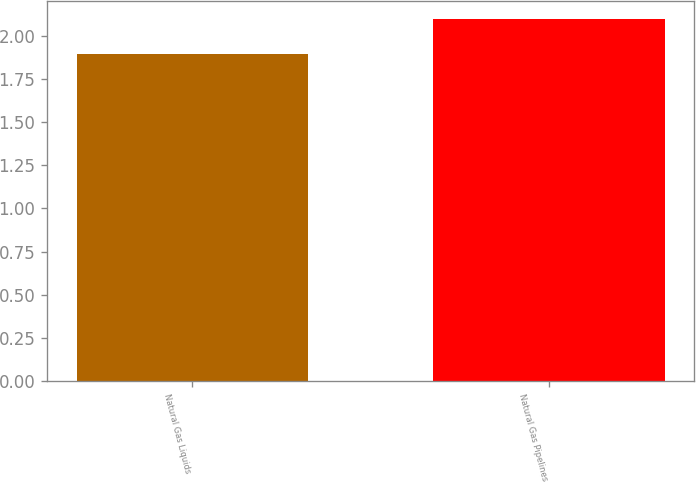Convert chart to OTSL. <chart><loc_0><loc_0><loc_500><loc_500><bar_chart><fcel>Natural Gas Liquids<fcel>Natural Gas Pipelines<nl><fcel>1.9<fcel>2.1<nl></chart> 